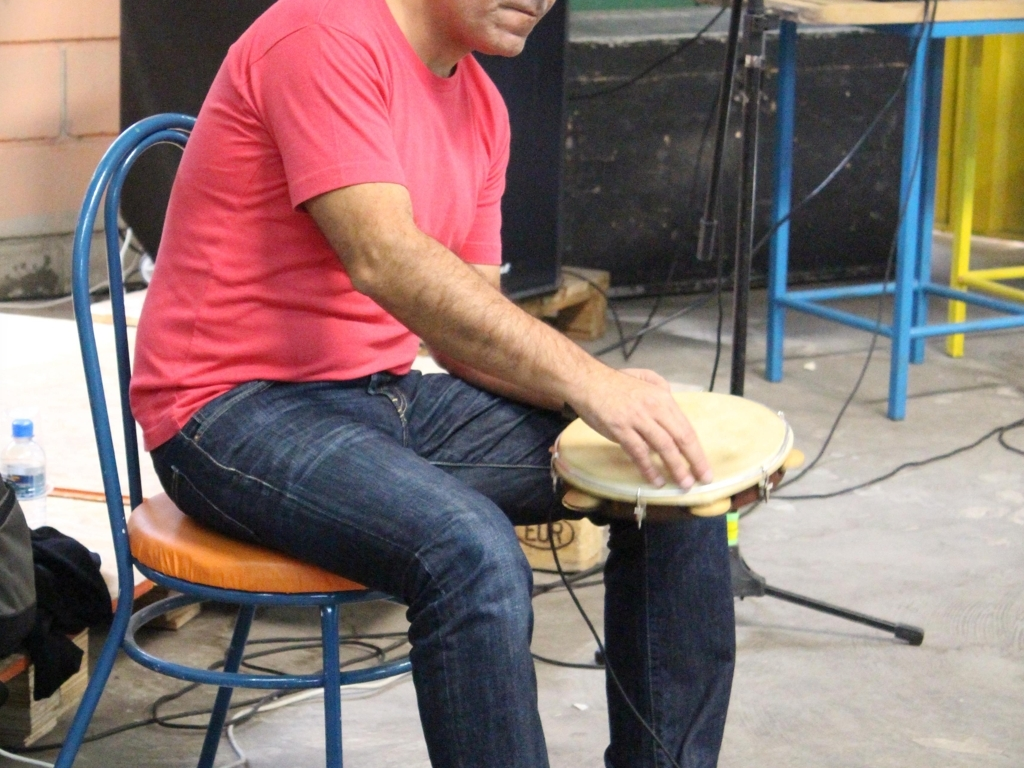The person seems to be in a rehearsal space, can music practice influence well-being? Absolutely, music practice has been shown to influence well-being positively. It engages the brain, can reduce stress, enhance cognitive functions, and provide an outlet for self-expression. Regular practice can also improve discipline and patience, while playing with others can foster social connections and a sense of community. What aspects in the background suggest it's a rehearsal space? The image shows a somewhat informal setting with a mix of equipment scattered around, such as a chair, wires on the ground, and a microphone stand, which suggests a practice or rehearsal scenario rather than a formal performance. The environment looks like it's designed for work and repetition, which are typical of a rehearsal space. 